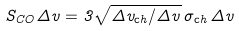Convert formula to latex. <formula><loc_0><loc_0><loc_500><loc_500>S _ { C O } \Delta v = 3 \sqrt { \Delta v _ { \mathrm c h } / \Delta v } \, \sigma _ { \mathrm c h } \, \Delta v</formula> 